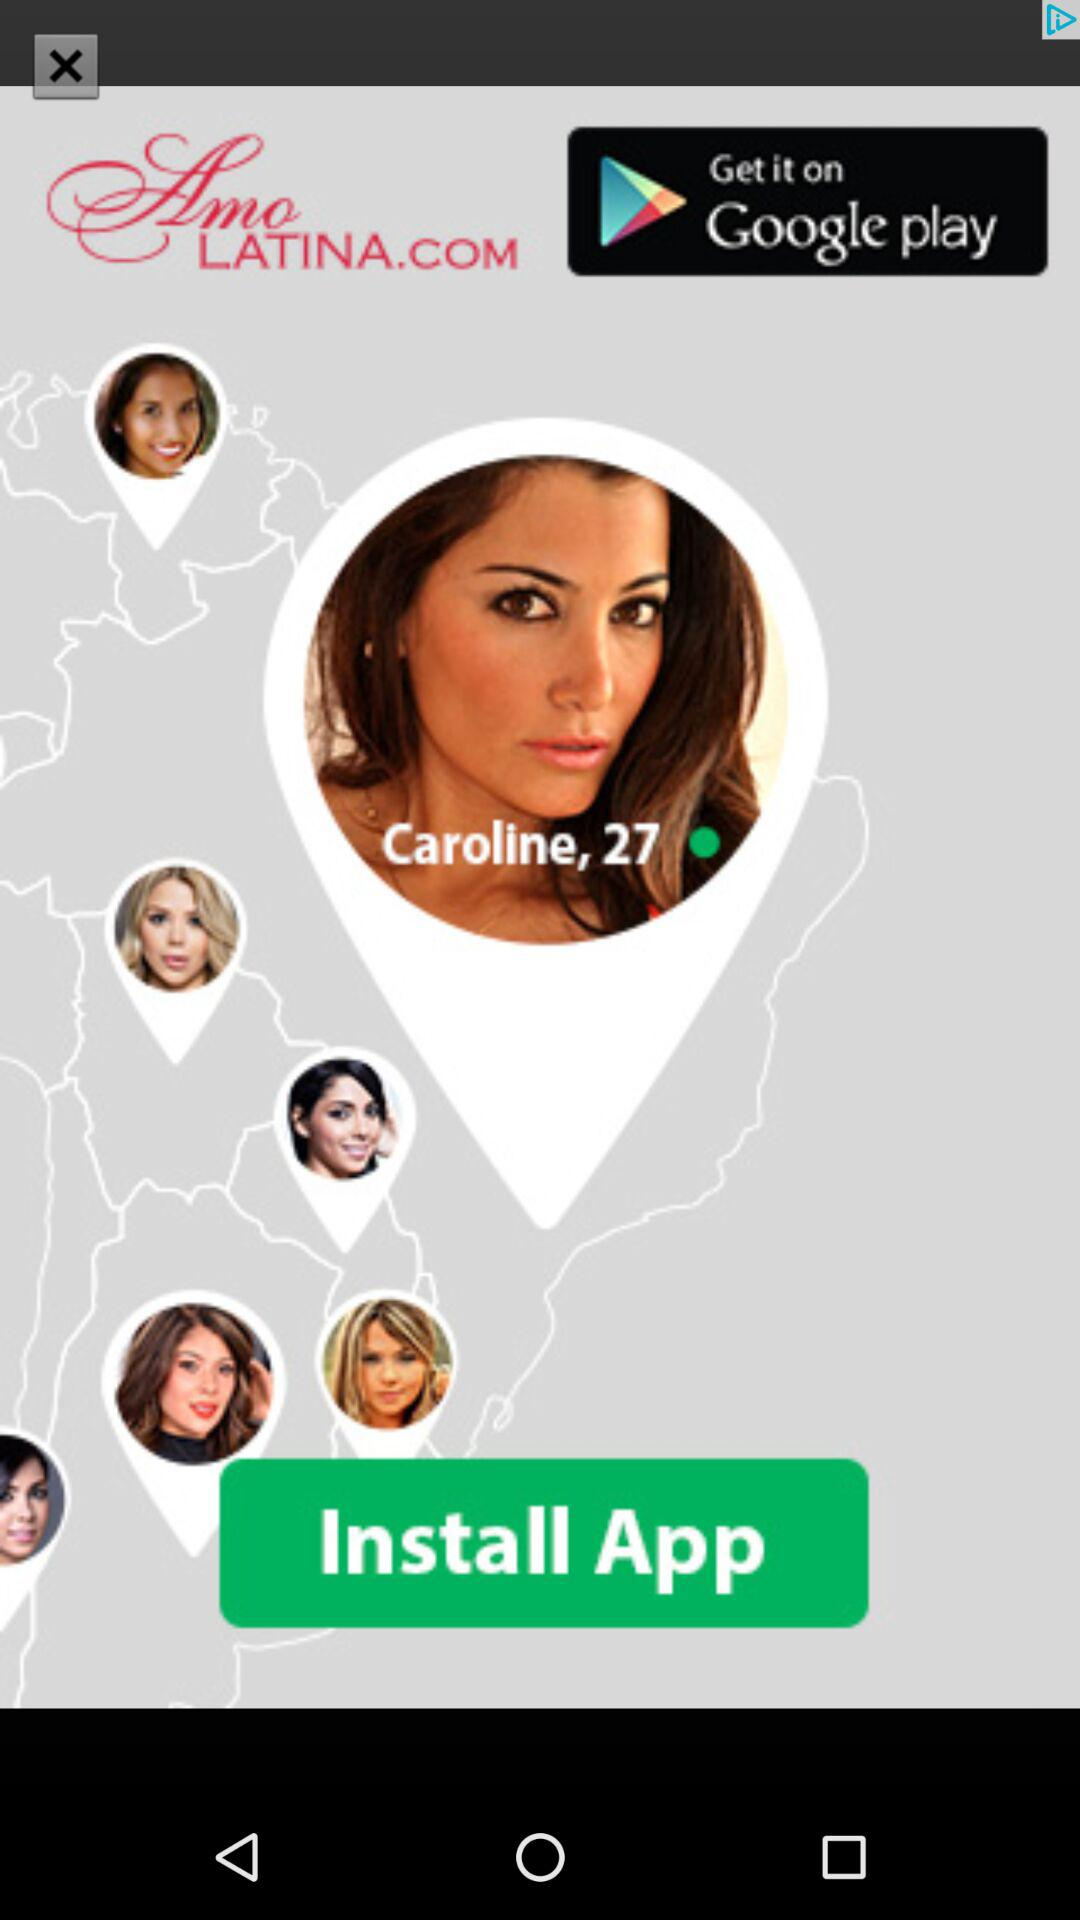What is the age of the user? The age of the user is 27 years. 